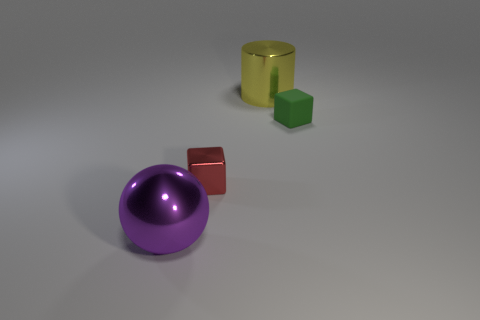Add 2 metal spheres. How many objects exist? 6 Subtract all balls. How many objects are left? 3 Subtract 0 cyan balls. How many objects are left? 4 Subtract all red things. Subtract all small green blocks. How many objects are left? 2 Add 1 cylinders. How many cylinders are left? 2 Add 3 small brown things. How many small brown things exist? 3 